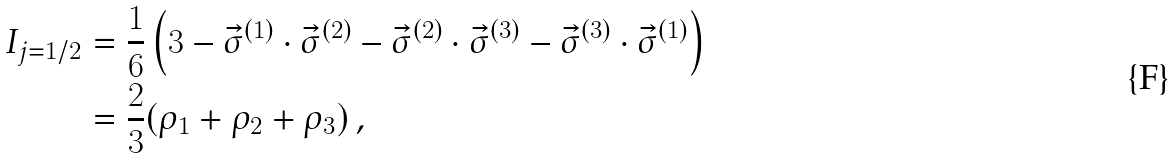Convert formula to latex. <formula><loc_0><loc_0><loc_500><loc_500>I _ { j = 1 / 2 } & = \frac { 1 } { 6 } \left ( 3 - \vec { \sigma } ^ { ( 1 ) } \cdot \vec { \sigma } ^ { ( 2 ) } - \vec { \sigma } ^ { ( 2 ) } \cdot \vec { \sigma } ^ { ( 3 ) } - \vec { \sigma } ^ { ( 3 ) } \cdot \vec { \sigma } ^ { ( 1 ) } \right ) \\ & = \frac { 2 } { 3 } ( \rho _ { 1 } + \rho _ { 2 } + \rho _ { 3 } ) \, ,</formula> 